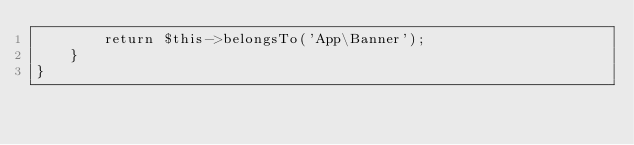<code> <loc_0><loc_0><loc_500><loc_500><_PHP_>        return $this->belongsTo('App\Banner');
    }
}
</code> 